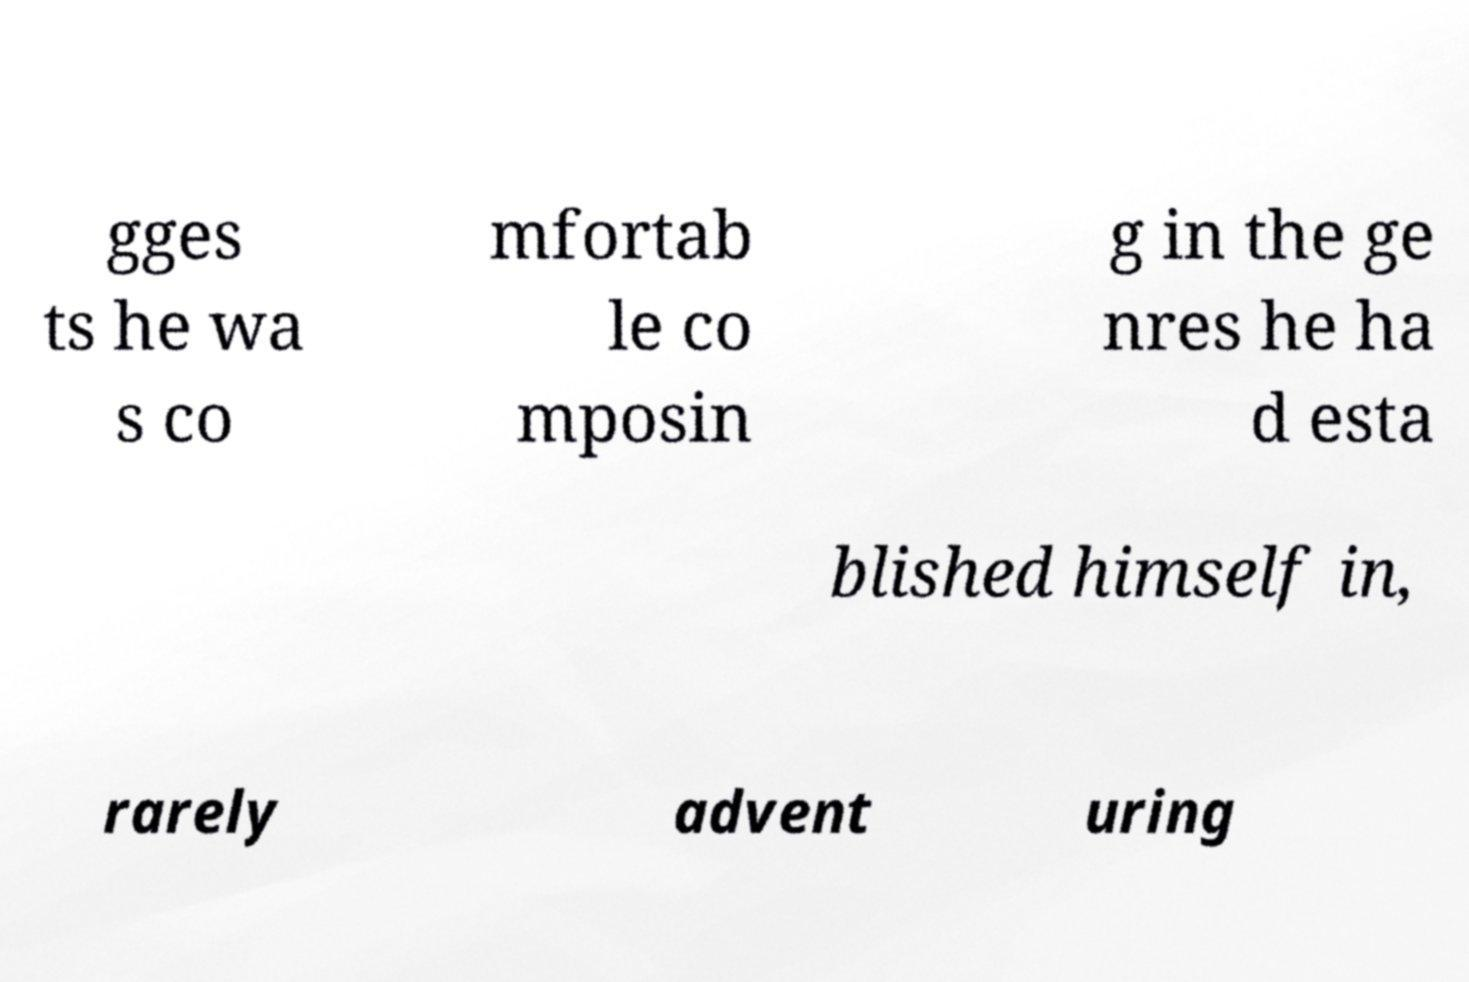Can you accurately transcribe the text from the provided image for me? gges ts he wa s co mfortab le co mposin g in the ge nres he ha d esta blished himself in, rarely advent uring 